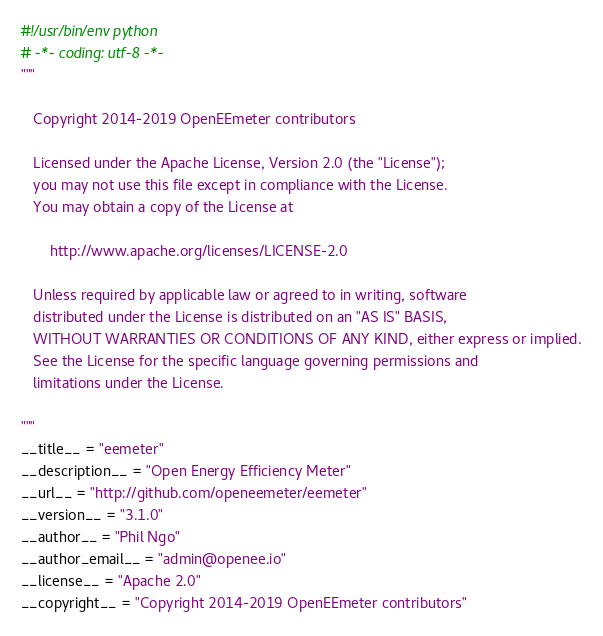Convert code to text. <code><loc_0><loc_0><loc_500><loc_500><_Python_>#!/usr/bin/env python
# -*- coding: utf-8 -*-
"""

   Copyright 2014-2019 OpenEEmeter contributors

   Licensed under the Apache License, Version 2.0 (the "License");
   you may not use this file except in compliance with the License.
   You may obtain a copy of the License at

       http://www.apache.org/licenses/LICENSE-2.0

   Unless required by applicable law or agreed to in writing, software
   distributed under the License is distributed on an "AS IS" BASIS,
   WITHOUT WARRANTIES OR CONDITIONS OF ANY KIND, either express or implied.
   See the License for the specific language governing permissions and
   limitations under the License.

"""
__title__ = "eemeter"
__description__ = "Open Energy Efficiency Meter"
__url__ = "http://github.com/openeemeter/eemeter"
__version__ = "3.1.0"
__author__ = "Phil Ngo"
__author_email__ = "admin@openee.io"
__license__ = "Apache 2.0"
__copyright__ = "Copyright 2014-2019 OpenEEmeter contributors"
</code> 